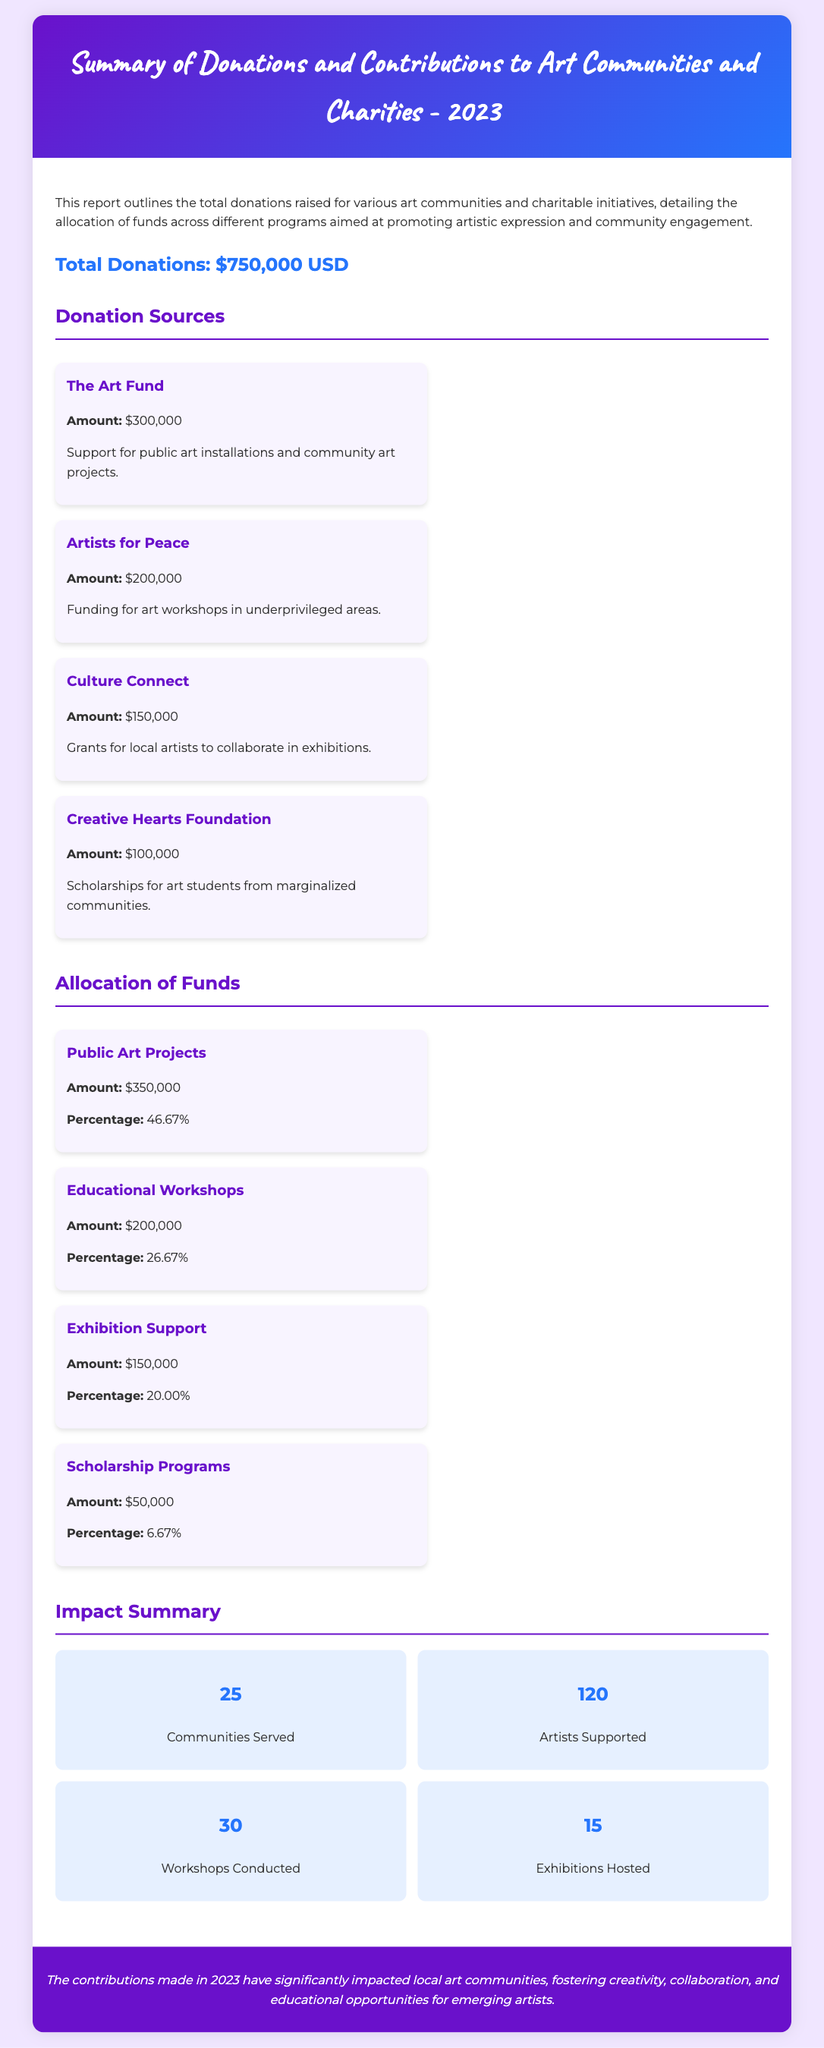What is the total amount of donations raised? The total donations raised is stated in the document as $750,000 USD.
Answer: $750,000 USD How much did The Art Fund contribute? The contribution from The Art Fund is clearly itemized in the donation sources section as $300,000.
Answer: $300,000 What percentage of the funds was allocated to Public Art Projects? The percentage allocated to Public Art Projects is mentioned as 46.67% in the allocation section.
Answer: 46.67% How many communities were served? The number of communities served is listed in the impact summary as 25.
Answer: 25 What is the total funding amount for Educational Workshops? The total funding for Educational Workshops is specifically noted as $200,000 in the allocation section.
Answer: $200,000 Which initiative received the least amount of funding? The initiative with the least amount of funding is Scholarship Programs, receiving $50,000.
Answer: Scholarship Programs What is the total number of artists supported? The total number of artists supported is listed in the impact summary as 120.
Answer: 120 Which donation source provided funding for art workshops? The donation source that provided funding for art workshops is Artists for Peace.
Answer: Artists for Peace 